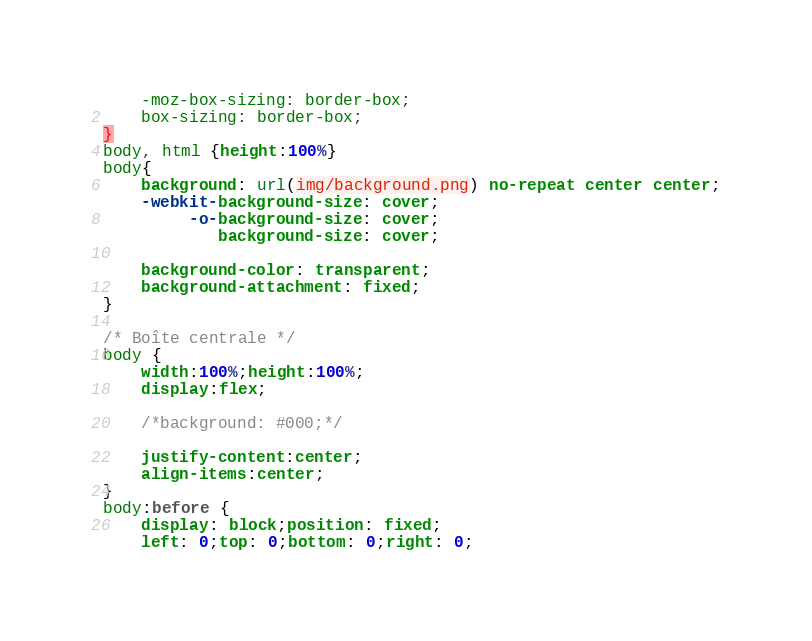Convert code to text. <code><loc_0><loc_0><loc_500><loc_500><_CSS_>	-moz-box-sizing: border-box;
	box-sizing: border-box;
}
body, html {height:100%}
body{
	background: url(img/background.png) no-repeat center center;
	-webkit-background-size: cover;
	     -o-background-size: cover;
	        background-size: cover;
	
	background-color: transparent;
    background-attachment: fixed;
}

/* Boîte centrale */
body {
	width:100%;height:100%;
	display:flex;
	
	/*background: #000;*/
	
	justify-content:center;
	align-items:center;
}
body:before {
	display: block;position: fixed;
	left: 0;top: 0;bottom: 0;right: 0;</code> 